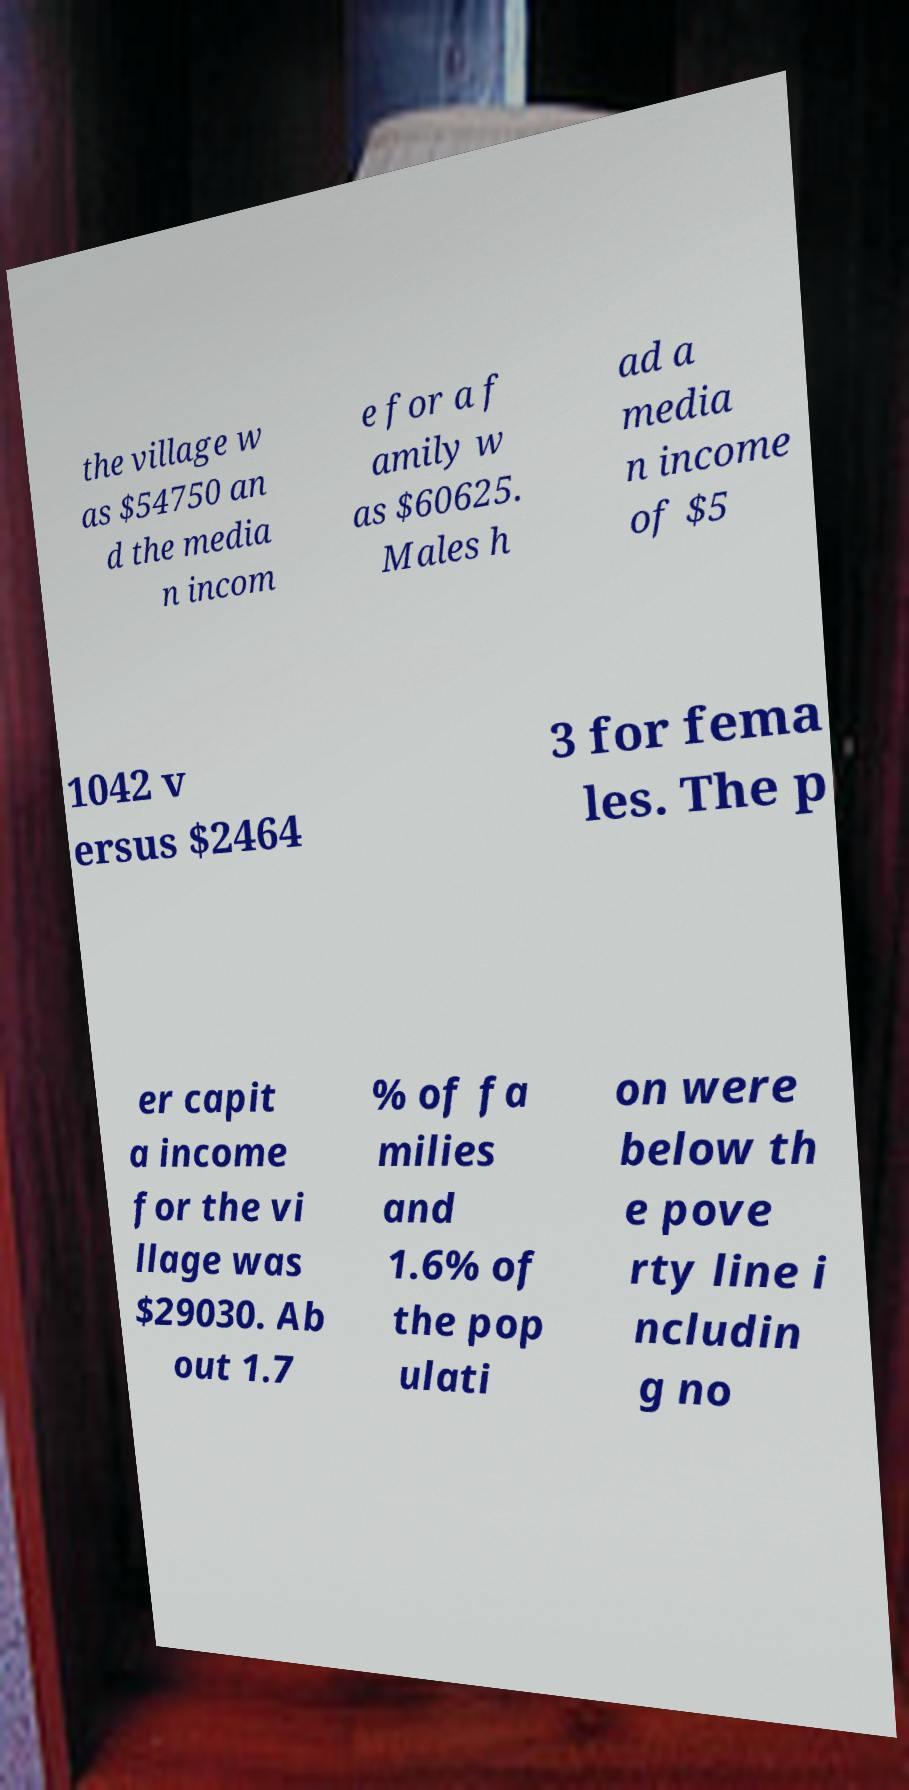Please read and relay the text visible in this image. What does it say? the village w as $54750 an d the media n incom e for a f amily w as $60625. Males h ad a media n income of $5 1042 v ersus $2464 3 for fema les. The p er capit a income for the vi llage was $29030. Ab out 1.7 % of fa milies and 1.6% of the pop ulati on were below th e pove rty line i ncludin g no 